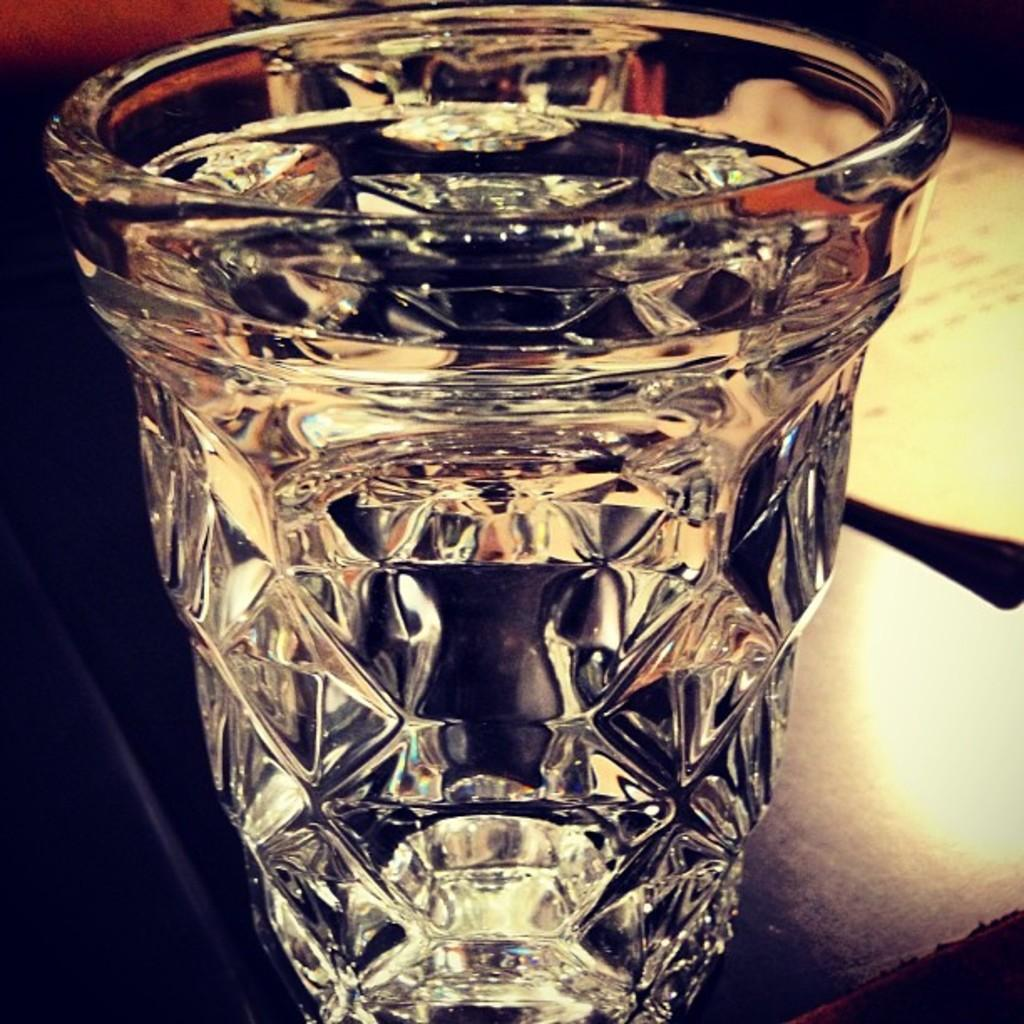What object is visible in the image? There is a glass in the image. Where is the glass located? The glass is placed on a table. Can you describe the background of the image? The background of the image is blurred. What type of nut is being cracked in the image? There is no nut present in the image; it only features a glass placed on a table with a blurred background. 